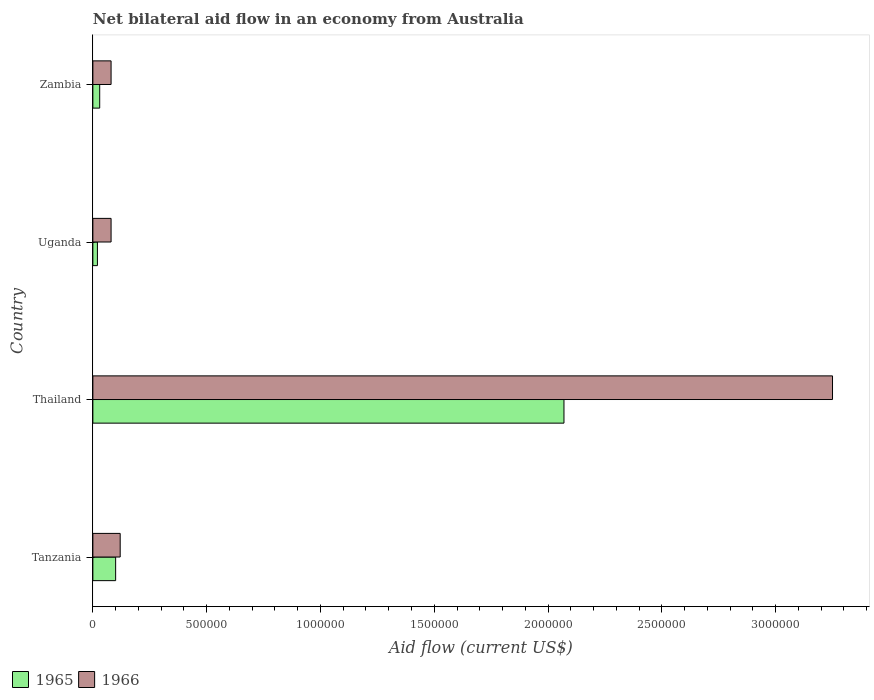How many groups of bars are there?
Offer a terse response. 4. Are the number of bars on each tick of the Y-axis equal?
Ensure brevity in your answer.  Yes. What is the label of the 4th group of bars from the top?
Give a very brief answer. Tanzania. In how many cases, is the number of bars for a given country not equal to the number of legend labels?
Your answer should be compact. 0. What is the net bilateral aid flow in 1966 in Zambia?
Your response must be concise. 8.00e+04. Across all countries, what is the maximum net bilateral aid flow in 1965?
Offer a terse response. 2.07e+06. In which country was the net bilateral aid flow in 1965 maximum?
Offer a terse response. Thailand. In which country was the net bilateral aid flow in 1966 minimum?
Offer a very short reply. Uganda. What is the total net bilateral aid flow in 1965 in the graph?
Provide a succinct answer. 2.22e+06. What is the difference between the net bilateral aid flow in 1965 in Uganda and the net bilateral aid flow in 1966 in Thailand?
Provide a succinct answer. -3.23e+06. What is the average net bilateral aid flow in 1966 per country?
Give a very brief answer. 8.82e+05. What is the difference between the net bilateral aid flow in 1966 and net bilateral aid flow in 1965 in Zambia?
Offer a terse response. 5.00e+04. In how many countries, is the net bilateral aid flow in 1965 greater than 2100000 US$?
Your answer should be very brief. 0. What is the ratio of the net bilateral aid flow in 1965 in Tanzania to that in Thailand?
Make the answer very short. 0.05. Is the difference between the net bilateral aid flow in 1966 in Thailand and Uganda greater than the difference between the net bilateral aid flow in 1965 in Thailand and Uganda?
Keep it short and to the point. Yes. What is the difference between the highest and the second highest net bilateral aid flow in 1965?
Offer a very short reply. 1.97e+06. What is the difference between the highest and the lowest net bilateral aid flow in 1965?
Offer a very short reply. 2.05e+06. Is the sum of the net bilateral aid flow in 1966 in Tanzania and Zambia greater than the maximum net bilateral aid flow in 1965 across all countries?
Your answer should be very brief. No. What does the 2nd bar from the top in Uganda represents?
Provide a short and direct response. 1965. What does the 1st bar from the bottom in Tanzania represents?
Make the answer very short. 1965. What is the difference between two consecutive major ticks on the X-axis?
Keep it short and to the point. 5.00e+05. Are the values on the major ticks of X-axis written in scientific E-notation?
Keep it short and to the point. No. Does the graph contain any zero values?
Ensure brevity in your answer.  No. How are the legend labels stacked?
Keep it short and to the point. Horizontal. What is the title of the graph?
Your response must be concise. Net bilateral aid flow in an economy from Australia. Does "1961" appear as one of the legend labels in the graph?
Your answer should be compact. No. What is the label or title of the X-axis?
Your answer should be very brief. Aid flow (current US$). What is the Aid flow (current US$) of 1965 in Thailand?
Offer a terse response. 2.07e+06. What is the Aid flow (current US$) of 1966 in Thailand?
Provide a short and direct response. 3.25e+06. What is the Aid flow (current US$) in 1966 in Uganda?
Make the answer very short. 8.00e+04. What is the Aid flow (current US$) in 1966 in Zambia?
Give a very brief answer. 8.00e+04. Across all countries, what is the maximum Aid flow (current US$) in 1965?
Your response must be concise. 2.07e+06. Across all countries, what is the maximum Aid flow (current US$) of 1966?
Offer a very short reply. 3.25e+06. Across all countries, what is the minimum Aid flow (current US$) in 1965?
Provide a short and direct response. 2.00e+04. Across all countries, what is the minimum Aid flow (current US$) of 1966?
Offer a very short reply. 8.00e+04. What is the total Aid flow (current US$) in 1965 in the graph?
Ensure brevity in your answer.  2.22e+06. What is the total Aid flow (current US$) of 1966 in the graph?
Keep it short and to the point. 3.53e+06. What is the difference between the Aid flow (current US$) of 1965 in Tanzania and that in Thailand?
Provide a short and direct response. -1.97e+06. What is the difference between the Aid flow (current US$) of 1966 in Tanzania and that in Thailand?
Provide a short and direct response. -3.13e+06. What is the difference between the Aid flow (current US$) in 1965 in Tanzania and that in Uganda?
Offer a terse response. 8.00e+04. What is the difference between the Aid flow (current US$) of 1965 in Thailand and that in Uganda?
Ensure brevity in your answer.  2.05e+06. What is the difference between the Aid flow (current US$) in 1966 in Thailand and that in Uganda?
Keep it short and to the point. 3.17e+06. What is the difference between the Aid flow (current US$) of 1965 in Thailand and that in Zambia?
Your response must be concise. 2.04e+06. What is the difference between the Aid flow (current US$) of 1966 in Thailand and that in Zambia?
Your answer should be compact. 3.17e+06. What is the difference between the Aid flow (current US$) of 1965 in Uganda and that in Zambia?
Provide a short and direct response. -10000. What is the difference between the Aid flow (current US$) of 1965 in Tanzania and the Aid flow (current US$) of 1966 in Thailand?
Keep it short and to the point. -3.15e+06. What is the difference between the Aid flow (current US$) of 1965 in Tanzania and the Aid flow (current US$) of 1966 in Uganda?
Make the answer very short. 2.00e+04. What is the difference between the Aid flow (current US$) in 1965 in Tanzania and the Aid flow (current US$) in 1966 in Zambia?
Provide a short and direct response. 2.00e+04. What is the difference between the Aid flow (current US$) in 1965 in Thailand and the Aid flow (current US$) in 1966 in Uganda?
Make the answer very short. 1.99e+06. What is the difference between the Aid flow (current US$) of 1965 in Thailand and the Aid flow (current US$) of 1966 in Zambia?
Offer a terse response. 1.99e+06. What is the difference between the Aid flow (current US$) of 1965 in Uganda and the Aid flow (current US$) of 1966 in Zambia?
Your response must be concise. -6.00e+04. What is the average Aid flow (current US$) of 1965 per country?
Provide a short and direct response. 5.55e+05. What is the average Aid flow (current US$) in 1966 per country?
Offer a very short reply. 8.82e+05. What is the difference between the Aid flow (current US$) of 1965 and Aid flow (current US$) of 1966 in Tanzania?
Your response must be concise. -2.00e+04. What is the difference between the Aid flow (current US$) of 1965 and Aid flow (current US$) of 1966 in Thailand?
Offer a very short reply. -1.18e+06. What is the difference between the Aid flow (current US$) of 1965 and Aid flow (current US$) of 1966 in Uganda?
Offer a very short reply. -6.00e+04. What is the ratio of the Aid flow (current US$) of 1965 in Tanzania to that in Thailand?
Make the answer very short. 0.05. What is the ratio of the Aid flow (current US$) of 1966 in Tanzania to that in Thailand?
Your response must be concise. 0.04. What is the ratio of the Aid flow (current US$) of 1965 in Tanzania to that in Uganda?
Offer a very short reply. 5. What is the ratio of the Aid flow (current US$) of 1966 in Tanzania to that in Zambia?
Give a very brief answer. 1.5. What is the ratio of the Aid flow (current US$) of 1965 in Thailand to that in Uganda?
Give a very brief answer. 103.5. What is the ratio of the Aid flow (current US$) in 1966 in Thailand to that in Uganda?
Offer a very short reply. 40.62. What is the ratio of the Aid flow (current US$) in 1965 in Thailand to that in Zambia?
Your answer should be compact. 69. What is the ratio of the Aid flow (current US$) of 1966 in Thailand to that in Zambia?
Keep it short and to the point. 40.62. What is the difference between the highest and the second highest Aid flow (current US$) of 1965?
Give a very brief answer. 1.97e+06. What is the difference between the highest and the second highest Aid flow (current US$) in 1966?
Your answer should be compact. 3.13e+06. What is the difference between the highest and the lowest Aid flow (current US$) of 1965?
Provide a short and direct response. 2.05e+06. What is the difference between the highest and the lowest Aid flow (current US$) of 1966?
Keep it short and to the point. 3.17e+06. 